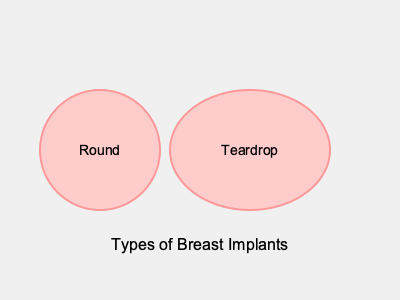Based on the visual representation, which type of breast implant appears to have a larger volume and more natural-looking shape for breast reconstruction after mastectomy? To answer this question, let's analyze the two types of breast implants shown in the image:

1. Round implant:
   - Represented by a perfect circle
   - Diameter is approximately 120 units
   - Provides a symmetrical shape

2. Teardrop implant:
   - Represented by an ellipse
   - Width (horizontal axis) is approximately 160 units
   - Height (vertical axis) is approximately 120 units
   - Has a more tapered shape at the top

Comparing the two:

1. Volume: The teardrop implant appears larger due to its wider horizontal axis.
   - Area of a circle (round): $A = \pi r^2 = \pi (60)^2 \approx 11,310$ square units
   - Area of an ellipse (teardrop): $A = \pi ab = \pi (80)(60) \approx 15,080$ square units

2. Natural-looking shape:
   - The teardrop implant has a gradual slope at the top, mimicking the natural breast shape
   - The round implant has equal fullness throughout, which may look less natural, especially in the upper pole

For breast reconstruction after mastectomy, a more natural-looking shape is often preferred to achieve a result similar to the original breast contour. The teardrop implant's larger volume and more anatomical shape make it appear more suitable for this purpose.
Answer: Teardrop implant 